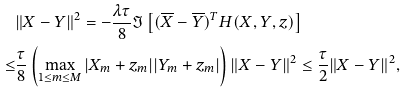Convert formula to latex. <formula><loc_0><loc_0><loc_500><loc_500>& \| X - Y \| ^ { 2 } = - \frac { \lambda \tau } 8 \Im \left [ ( \overline { X } - \overline { Y } ) ^ { T } H ( X , Y , z ) \right ] \\ \leq & \frac { \tau } { 8 } \left ( \max _ { 1 \leq m \leq M } | X _ { m } + z _ { m } | | Y _ { m } + z _ { m } | \right ) \| X - Y \| ^ { 2 } \leq \frac { \tau } 2 \| X - Y \| ^ { 2 } ,</formula> 